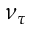<formula> <loc_0><loc_0><loc_500><loc_500>\nu _ { \tau }</formula> 